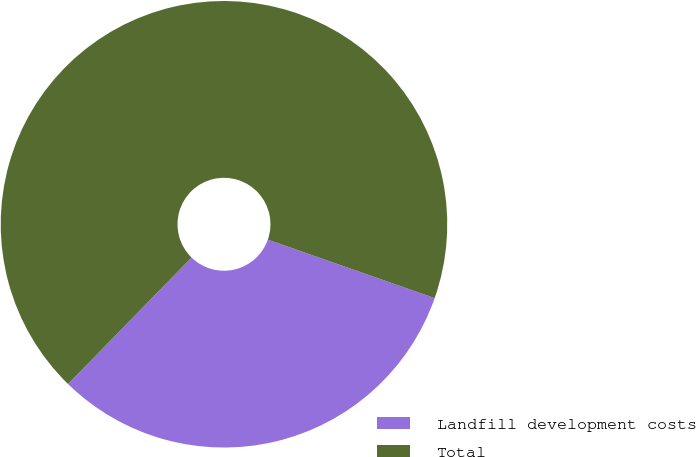<chart> <loc_0><loc_0><loc_500><loc_500><pie_chart><fcel>Landfill development costs<fcel>Total<nl><fcel>31.94%<fcel>68.06%<nl></chart> 